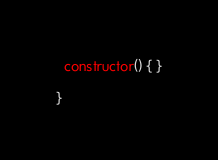<code> <loc_0><loc_0><loc_500><loc_500><_TypeScript_>  constructor() { }

}
</code> 